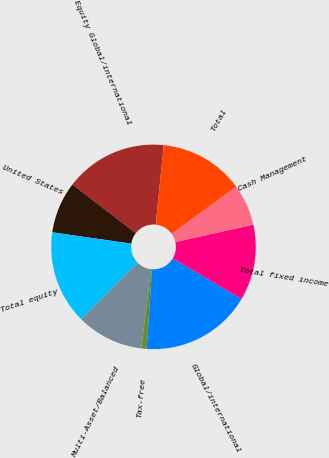<chart> <loc_0><loc_0><loc_500><loc_500><pie_chart><fcel>Equity Global/international<fcel>United States<fcel>Total equity<fcel>Multi-Asset/Balanced<fcel>Tax-free<fcel>Global/international<fcel>Total fixed income<fcel>Cash Management<fcel>Total<nl><fcel>16.16%<fcel>8.16%<fcel>14.78%<fcel>10.61%<fcel>0.82%<fcel>17.55%<fcel>12.0%<fcel>6.53%<fcel>13.39%<nl></chart> 